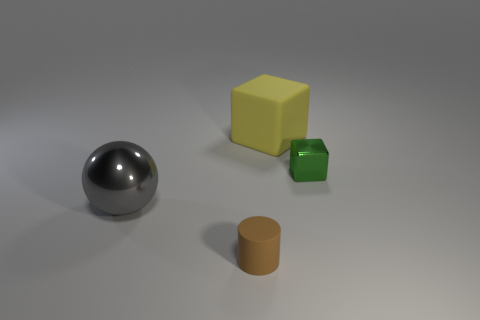Are there an equal number of yellow rubber cubes that are left of the metal ball and things in front of the cylinder?
Your response must be concise. Yes. There is a big thing to the right of the cylinder; how many small green blocks are left of it?
Keep it short and to the point. 0. There is a rubber object in front of the green metal cube; is its color the same as the metallic thing on the left side of the tiny rubber object?
Make the answer very short. No. What material is the gray ball that is the same size as the matte cube?
Provide a succinct answer. Metal. There is a big object that is right of the thing that is left of the tiny object that is to the left of the green metal thing; what shape is it?
Offer a terse response. Cube. The other thing that is the same size as the green object is what shape?
Offer a terse response. Cylinder. What number of large objects are in front of the block that is in front of the rubber object that is behind the tiny cylinder?
Your answer should be compact. 1. Is the number of big metallic objects in front of the tiny brown rubber thing greater than the number of tiny matte things behind the big yellow rubber block?
Your response must be concise. No. What number of green metallic things are the same shape as the large rubber object?
Your response must be concise. 1. How many things are things that are on the left side of the shiny block or tiny things that are behind the large gray metallic sphere?
Provide a succinct answer. 4. 